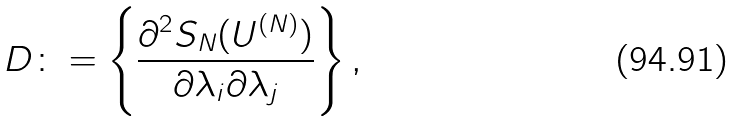Convert formula to latex. <formula><loc_0><loc_0><loc_500><loc_500>D \colon = \left \{ \frac { \partial ^ { 2 } S _ { N } ( U ^ { ( N ) } ) } { \partial \lambda _ { i } \partial \lambda _ { j } } \right \} ,</formula> 